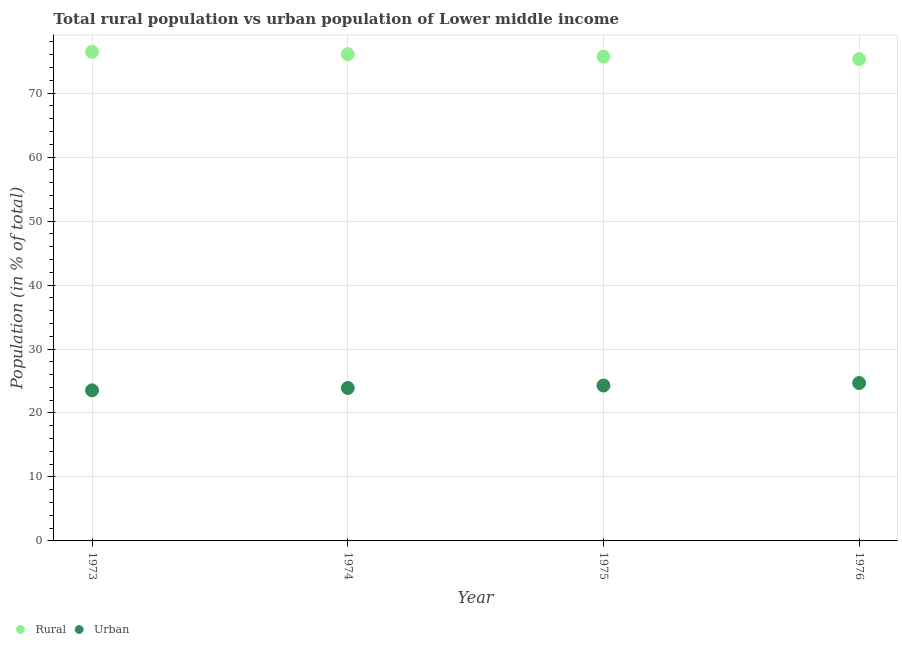Is the number of dotlines equal to the number of legend labels?
Offer a very short reply. Yes. What is the urban population in 1974?
Provide a short and direct response. 23.91. Across all years, what is the maximum urban population?
Make the answer very short. 24.68. Across all years, what is the minimum rural population?
Give a very brief answer. 75.32. In which year was the urban population maximum?
Your answer should be compact. 1976. In which year was the urban population minimum?
Offer a terse response. 1973. What is the total urban population in the graph?
Ensure brevity in your answer.  96.42. What is the difference between the rural population in 1973 and that in 1975?
Keep it short and to the point. 0.76. What is the difference between the urban population in 1976 and the rural population in 1973?
Your answer should be compact. -51.78. What is the average rural population per year?
Give a very brief answer. 75.9. In the year 1973, what is the difference between the urban population and rural population?
Offer a very short reply. -52.93. What is the ratio of the urban population in 1973 to that in 1975?
Provide a succinct answer. 0.97. Is the urban population in 1973 less than that in 1975?
Give a very brief answer. Yes. Is the difference between the urban population in 1974 and 1976 greater than the difference between the rural population in 1974 and 1976?
Make the answer very short. No. What is the difference between the highest and the second highest rural population?
Offer a terse response. 0.37. What is the difference between the highest and the lowest urban population?
Your answer should be very brief. 1.14. In how many years, is the rural population greater than the average rural population taken over all years?
Give a very brief answer. 2. Is the sum of the urban population in 1974 and 1975 greater than the maximum rural population across all years?
Keep it short and to the point. No. Is the rural population strictly greater than the urban population over the years?
Provide a short and direct response. Yes. How many years are there in the graph?
Provide a succinct answer. 4. What is the difference between two consecutive major ticks on the Y-axis?
Provide a short and direct response. 10. Does the graph contain grids?
Your answer should be compact. Yes. What is the title of the graph?
Ensure brevity in your answer.  Total rural population vs urban population of Lower middle income. Does "GDP" appear as one of the legend labels in the graph?
Provide a short and direct response. No. What is the label or title of the Y-axis?
Ensure brevity in your answer.  Population (in % of total). What is the Population (in % of total) in Rural in 1973?
Keep it short and to the point. 76.46. What is the Population (in % of total) of Urban in 1973?
Make the answer very short. 23.54. What is the Population (in % of total) in Rural in 1974?
Ensure brevity in your answer.  76.09. What is the Population (in % of total) in Urban in 1974?
Provide a succinct answer. 23.91. What is the Population (in % of total) of Rural in 1975?
Provide a short and direct response. 75.71. What is the Population (in % of total) of Urban in 1975?
Keep it short and to the point. 24.29. What is the Population (in % of total) in Rural in 1976?
Make the answer very short. 75.32. What is the Population (in % of total) in Urban in 1976?
Make the answer very short. 24.68. Across all years, what is the maximum Population (in % of total) in Rural?
Make the answer very short. 76.46. Across all years, what is the maximum Population (in % of total) in Urban?
Your response must be concise. 24.68. Across all years, what is the minimum Population (in % of total) of Rural?
Give a very brief answer. 75.32. Across all years, what is the minimum Population (in % of total) of Urban?
Your answer should be very brief. 23.54. What is the total Population (in % of total) in Rural in the graph?
Make the answer very short. 303.58. What is the total Population (in % of total) in Urban in the graph?
Offer a terse response. 96.42. What is the difference between the Population (in % of total) in Rural in 1973 and that in 1974?
Offer a very short reply. 0.37. What is the difference between the Population (in % of total) in Urban in 1973 and that in 1974?
Make the answer very short. -0.37. What is the difference between the Population (in % of total) of Rural in 1973 and that in 1975?
Keep it short and to the point. 0.76. What is the difference between the Population (in % of total) of Urban in 1973 and that in 1975?
Your response must be concise. -0.76. What is the difference between the Population (in % of total) of Rural in 1973 and that in 1976?
Ensure brevity in your answer.  1.14. What is the difference between the Population (in % of total) in Urban in 1973 and that in 1976?
Your answer should be very brief. -1.14. What is the difference between the Population (in % of total) of Rural in 1974 and that in 1975?
Make the answer very short. 0.39. What is the difference between the Population (in % of total) of Urban in 1974 and that in 1975?
Provide a succinct answer. -0.39. What is the difference between the Population (in % of total) of Rural in 1974 and that in 1976?
Give a very brief answer. 0.77. What is the difference between the Population (in % of total) in Urban in 1974 and that in 1976?
Provide a short and direct response. -0.77. What is the difference between the Population (in % of total) in Rural in 1975 and that in 1976?
Provide a succinct answer. 0.39. What is the difference between the Population (in % of total) in Urban in 1975 and that in 1976?
Ensure brevity in your answer.  -0.39. What is the difference between the Population (in % of total) of Rural in 1973 and the Population (in % of total) of Urban in 1974?
Keep it short and to the point. 52.56. What is the difference between the Population (in % of total) in Rural in 1973 and the Population (in % of total) in Urban in 1975?
Offer a terse response. 52.17. What is the difference between the Population (in % of total) of Rural in 1973 and the Population (in % of total) of Urban in 1976?
Your answer should be very brief. 51.78. What is the difference between the Population (in % of total) in Rural in 1974 and the Population (in % of total) in Urban in 1975?
Provide a short and direct response. 51.8. What is the difference between the Population (in % of total) of Rural in 1974 and the Population (in % of total) of Urban in 1976?
Make the answer very short. 51.41. What is the difference between the Population (in % of total) of Rural in 1975 and the Population (in % of total) of Urban in 1976?
Ensure brevity in your answer.  51.02. What is the average Population (in % of total) in Rural per year?
Ensure brevity in your answer.  75.9. What is the average Population (in % of total) of Urban per year?
Ensure brevity in your answer.  24.1. In the year 1973, what is the difference between the Population (in % of total) in Rural and Population (in % of total) in Urban?
Keep it short and to the point. 52.93. In the year 1974, what is the difference between the Population (in % of total) in Rural and Population (in % of total) in Urban?
Offer a very short reply. 52.19. In the year 1975, what is the difference between the Population (in % of total) in Rural and Population (in % of total) in Urban?
Provide a succinct answer. 51.41. In the year 1976, what is the difference between the Population (in % of total) in Rural and Population (in % of total) in Urban?
Make the answer very short. 50.64. What is the ratio of the Population (in % of total) in Urban in 1973 to that in 1974?
Your response must be concise. 0.98. What is the ratio of the Population (in % of total) in Rural in 1973 to that in 1975?
Keep it short and to the point. 1.01. What is the ratio of the Population (in % of total) of Urban in 1973 to that in 1975?
Offer a terse response. 0.97. What is the ratio of the Population (in % of total) in Rural in 1973 to that in 1976?
Offer a terse response. 1.02. What is the ratio of the Population (in % of total) in Urban in 1973 to that in 1976?
Provide a short and direct response. 0.95. What is the ratio of the Population (in % of total) of Rural in 1974 to that in 1975?
Offer a terse response. 1.01. What is the ratio of the Population (in % of total) in Urban in 1974 to that in 1975?
Your answer should be very brief. 0.98. What is the ratio of the Population (in % of total) of Rural in 1974 to that in 1976?
Ensure brevity in your answer.  1.01. What is the ratio of the Population (in % of total) in Urban in 1974 to that in 1976?
Provide a short and direct response. 0.97. What is the ratio of the Population (in % of total) in Urban in 1975 to that in 1976?
Offer a terse response. 0.98. What is the difference between the highest and the second highest Population (in % of total) of Rural?
Offer a very short reply. 0.37. What is the difference between the highest and the second highest Population (in % of total) of Urban?
Make the answer very short. 0.39. What is the difference between the highest and the lowest Population (in % of total) of Rural?
Provide a succinct answer. 1.14. What is the difference between the highest and the lowest Population (in % of total) of Urban?
Give a very brief answer. 1.14. 